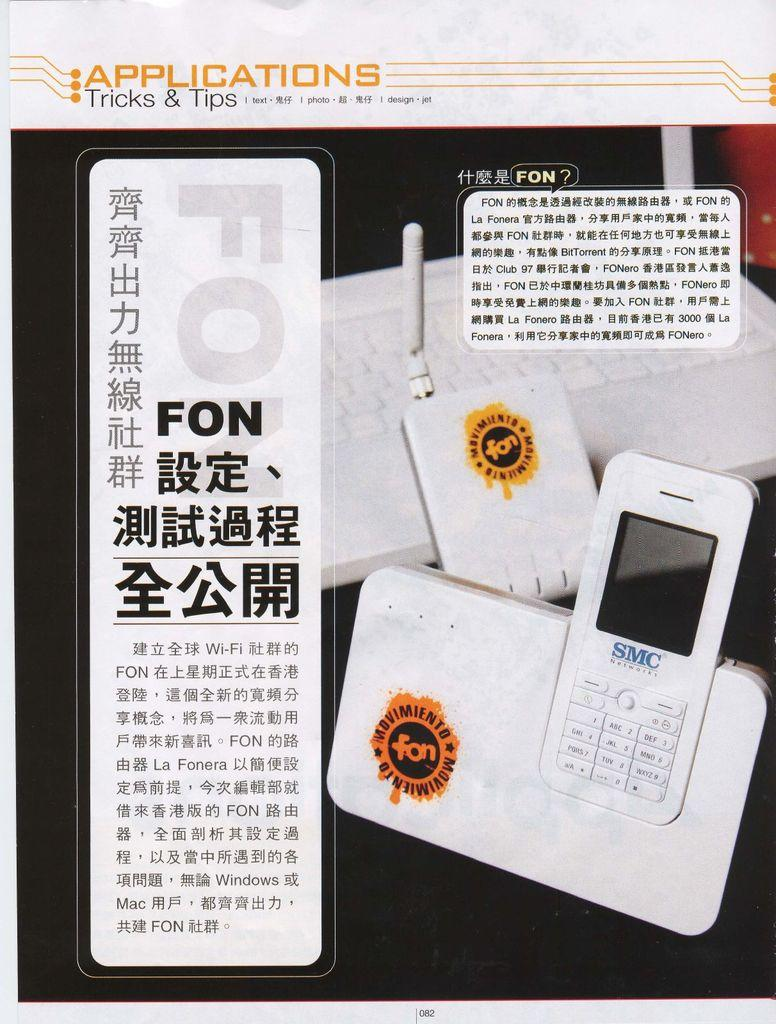<image>
Write a terse but informative summary of the picture. An applications tricks and tips page for a phone written in an Asian language. 